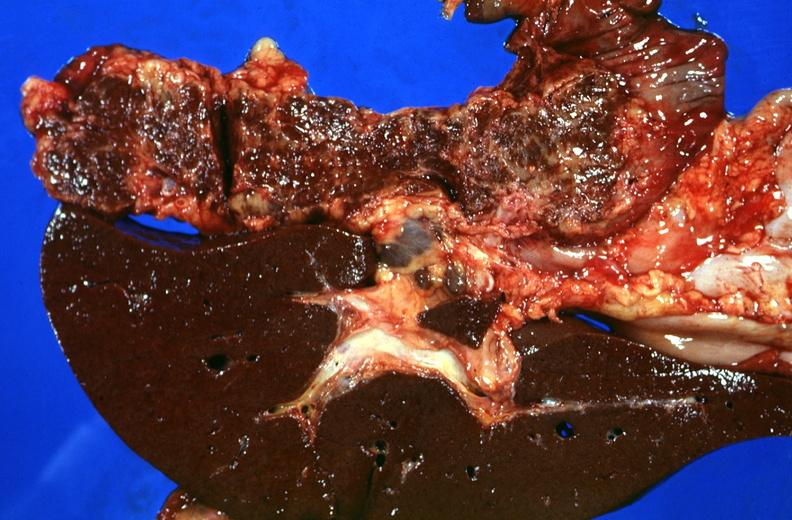what does this image show?
Answer the question using a single word or phrase. Liver and pancreas 